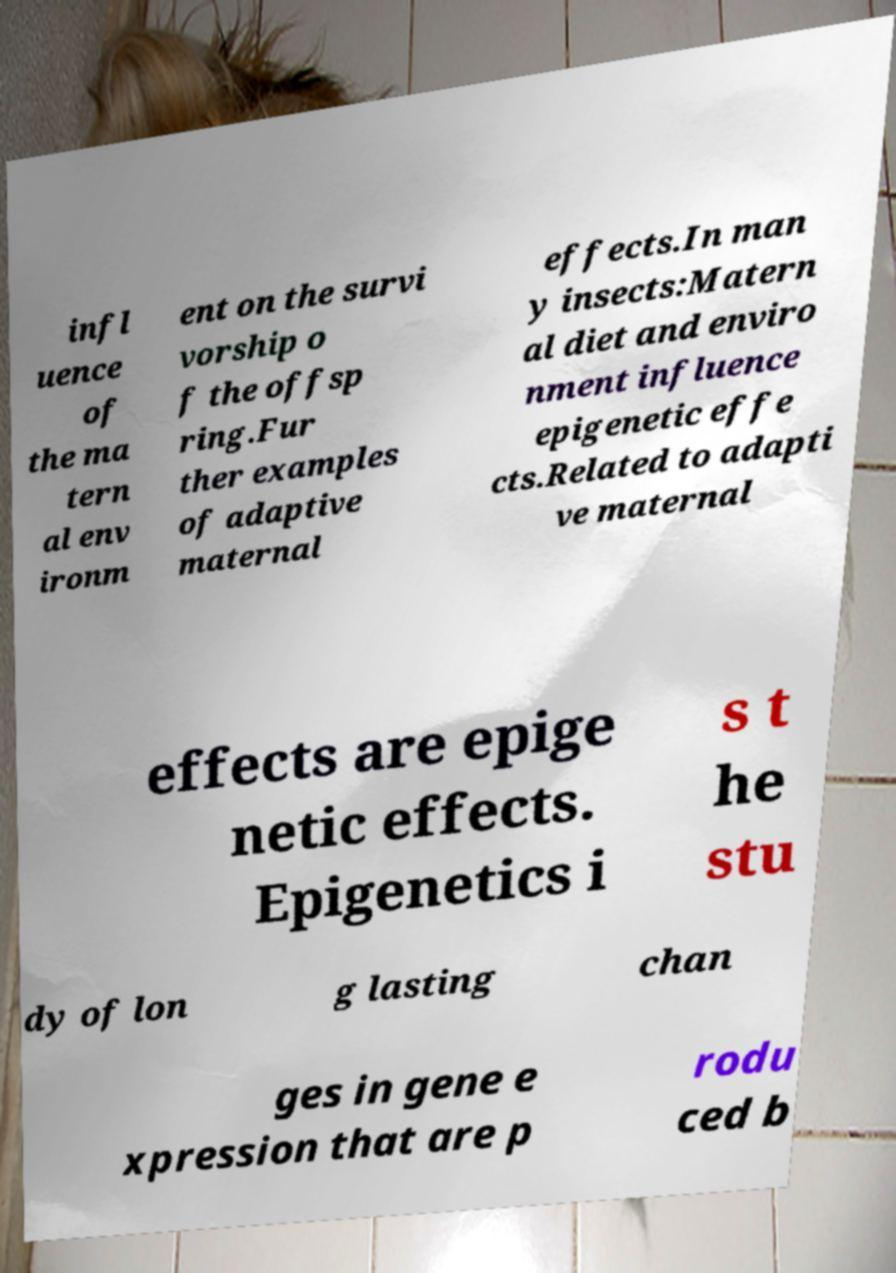Please read and relay the text visible in this image. What does it say? infl uence of the ma tern al env ironm ent on the survi vorship o f the offsp ring.Fur ther examples of adaptive maternal effects.In man y insects:Matern al diet and enviro nment influence epigenetic effe cts.Related to adapti ve maternal effects are epige netic effects. Epigenetics i s t he stu dy of lon g lasting chan ges in gene e xpression that are p rodu ced b 